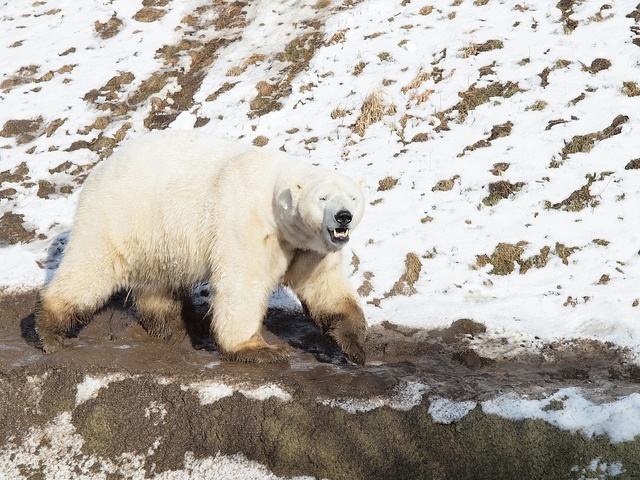Describe the objects in this image and their specific colors. I can see a bear in white, ivory, tan, gray, and darkgray tones in this image. 